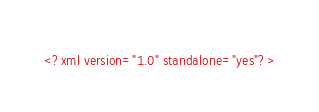Convert code to text. <code><loc_0><loc_0><loc_500><loc_500><_XML_><?xml version="1.0" standalone="yes"?>
</code> 